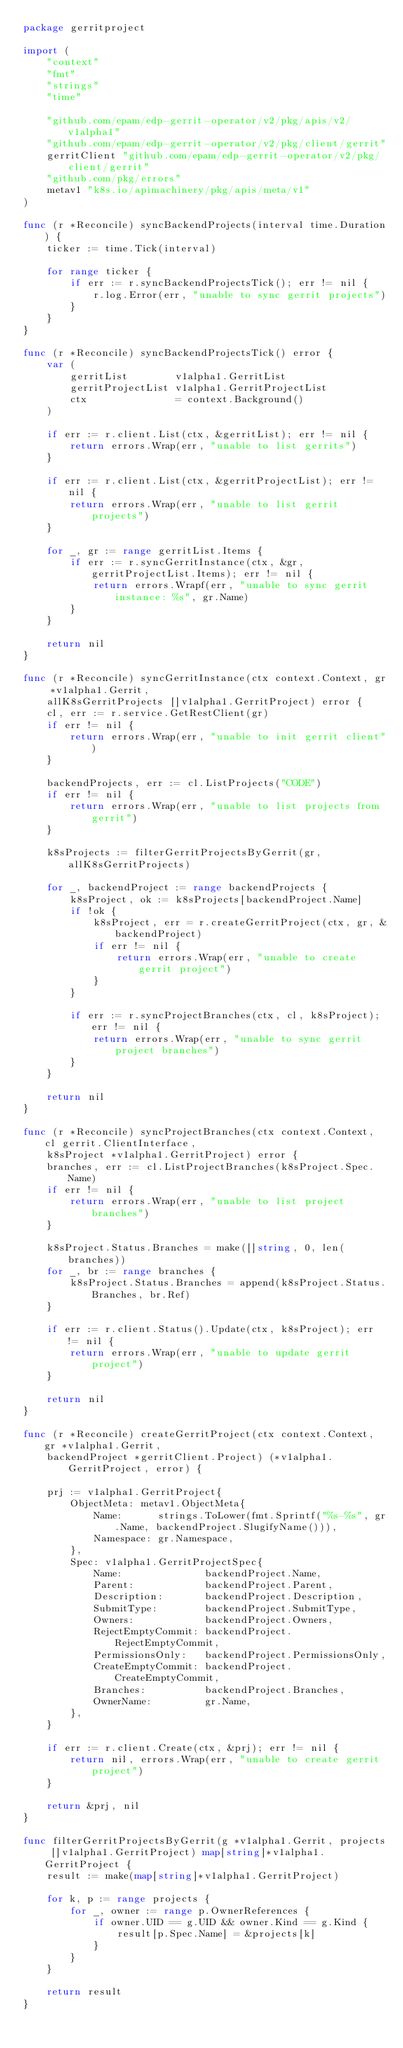Convert code to text. <code><loc_0><loc_0><loc_500><loc_500><_Go_>package gerritproject

import (
	"context"
	"fmt"
	"strings"
	"time"

	"github.com/epam/edp-gerrit-operator/v2/pkg/apis/v2/v1alpha1"
	"github.com/epam/edp-gerrit-operator/v2/pkg/client/gerrit"
	gerritClient "github.com/epam/edp-gerrit-operator/v2/pkg/client/gerrit"
	"github.com/pkg/errors"
	metav1 "k8s.io/apimachinery/pkg/apis/meta/v1"
)

func (r *Reconcile) syncBackendProjects(interval time.Duration) {
	ticker := time.Tick(interval)

	for range ticker {
		if err := r.syncBackendProjectsTick(); err != nil {
			r.log.Error(err, "unable to sync gerrit projects")
		}
	}
}

func (r *Reconcile) syncBackendProjectsTick() error {
	var (
		gerritList        v1alpha1.GerritList
		gerritProjectList v1alpha1.GerritProjectList
		ctx               = context.Background()
	)

	if err := r.client.List(ctx, &gerritList); err != nil {
		return errors.Wrap(err, "unable to list gerrits")
	}

	if err := r.client.List(ctx, &gerritProjectList); err != nil {
		return errors.Wrap(err, "unable to list gerrit projects")
	}

	for _, gr := range gerritList.Items {
		if err := r.syncGerritInstance(ctx, &gr, gerritProjectList.Items); err != nil {
			return errors.Wrapf(err, "unable to sync gerrit instance: %s", gr.Name)
		}
	}

	return nil
}

func (r *Reconcile) syncGerritInstance(ctx context.Context, gr *v1alpha1.Gerrit,
	allK8sGerritProjects []v1alpha1.GerritProject) error {
	cl, err := r.service.GetRestClient(gr)
	if err != nil {
		return errors.Wrap(err, "unable to init gerrit client")
	}

	backendProjects, err := cl.ListProjects("CODE")
	if err != nil {
		return errors.Wrap(err, "unable to list projects from gerrit")
	}

	k8sProjects := filterGerritProjectsByGerrit(gr, allK8sGerritProjects)

	for _, backendProject := range backendProjects {
		k8sProject, ok := k8sProjects[backendProject.Name]
		if !ok {
			k8sProject, err = r.createGerritProject(ctx, gr, &backendProject)
			if err != nil {
				return errors.Wrap(err, "unable to create gerrit project")
			}
		}

		if err := r.syncProjectBranches(ctx, cl, k8sProject); err != nil {
			return errors.Wrap(err, "unable to sync gerrit project branches")
		}
	}

	return nil
}

func (r *Reconcile) syncProjectBranches(ctx context.Context, cl gerrit.ClientInterface,
	k8sProject *v1alpha1.GerritProject) error {
	branches, err := cl.ListProjectBranches(k8sProject.Spec.Name)
	if err != nil {
		return errors.Wrap(err, "unable to list project branches")
	}

	k8sProject.Status.Branches = make([]string, 0, len(branches))
	for _, br := range branches {
		k8sProject.Status.Branches = append(k8sProject.Status.Branches, br.Ref)
	}

	if err := r.client.Status().Update(ctx, k8sProject); err != nil {
		return errors.Wrap(err, "unable to update gerrit project")
	}

	return nil
}

func (r *Reconcile) createGerritProject(ctx context.Context, gr *v1alpha1.Gerrit,
	backendProject *gerritClient.Project) (*v1alpha1.GerritProject, error) {

	prj := v1alpha1.GerritProject{
		ObjectMeta: metav1.ObjectMeta{
			Name:      strings.ToLower(fmt.Sprintf("%s-%s", gr.Name, backendProject.SlugifyName())),
			Namespace: gr.Namespace,
		},
		Spec: v1alpha1.GerritProjectSpec{
			Name:              backendProject.Name,
			Parent:            backendProject.Parent,
			Description:       backendProject.Description,
			SubmitType:        backendProject.SubmitType,
			Owners:            backendProject.Owners,
			RejectEmptyCommit: backendProject.RejectEmptyCommit,
			PermissionsOnly:   backendProject.PermissionsOnly,
			CreateEmptyCommit: backendProject.CreateEmptyCommit,
			Branches:          backendProject.Branches,
			OwnerName:         gr.Name,
		},
	}

	if err := r.client.Create(ctx, &prj); err != nil {
		return nil, errors.Wrap(err, "unable to create gerrit project")
	}

	return &prj, nil
}

func filterGerritProjectsByGerrit(g *v1alpha1.Gerrit, projects []v1alpha1.GerritProject) map[string]*v1alpha1.GerritProject {
	result := make(map[string]*v1alpha1.GerritProject)

	for k, p := range projects {
		for _, owner := range p.OwnerReferences {
			if owner.UID == g.UID && owner.Kind == g.Kind {
				result[p.Spec.Name] = &projects[k]
			}
		}
	}

	return result
}
</code> 